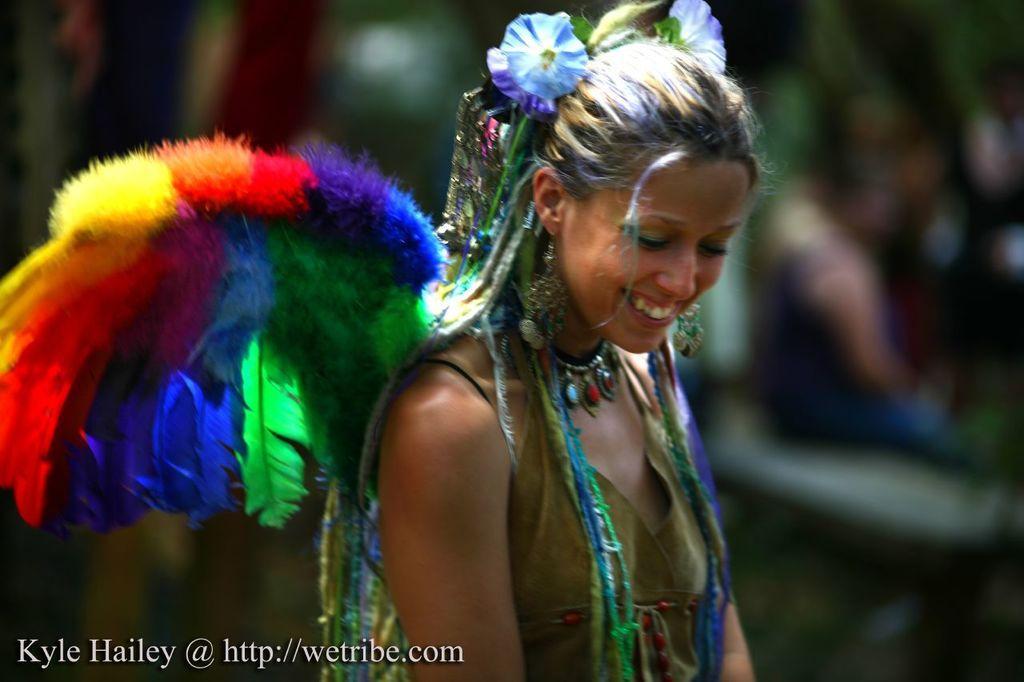Please provide a concise description of this image. In the center of the image a lady is smiling and wearing costume. At the bottom left corner we can see some text. In the background the image is blur. 